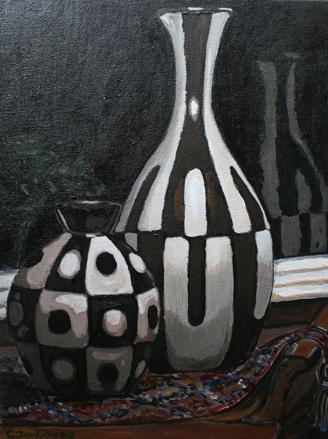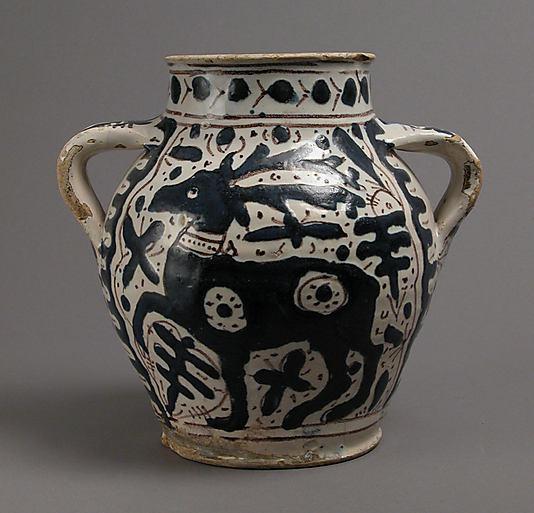The first image is the image on the left, the second image is the image on the right. For the images displayed, is the sentence "One vessel has at least one handle, is widest around the middle, and features a stylized depiction of a hooved animal in black." factually correct? Answer yes or no. Yes. The first image is the image on the left, the second image is the image on the right. Considering the images on both sides, is "The vase in the image on the left has two handles." valid? Answer yes or no. No. 